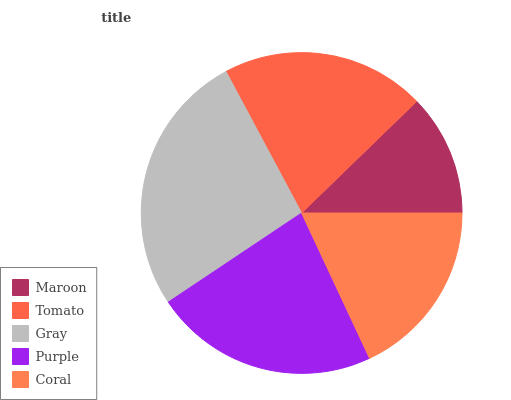Is Maroon the minimum?
Answer yes or no. Yes. Is Gray the maximum?
Answer yes or no. Yes. Is Tomato the minimum?
Answer yes or no. No. Is Tomato the maximum?
Answer yes or no. No. Is Tomato greater than Maroon?
Answer yes or no. Yes. Is Maroon less than Tomato?
Answer yes or no. Yes. Is Maroon greater than Tomato?
Answer yes or no. No. Is Tomato less than Maroon?
Answer yes or no. No. Is Tomato the high median?
Answer yes or no. Yes. Is Tomato the low median?
Answer yes or no. Yes. Is Purple the high median?
Answer yes or no. No. Is Maroon the low median?
Answer yes or no. No. 